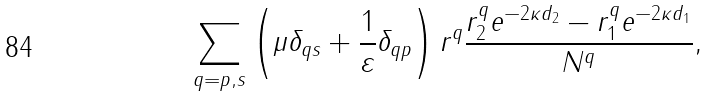<formula> <loc_0><loc_0><loc_500><loc_500>\sum _ { q = p , s } \left ( \mu \delta _ { q s } + \frac { 1 } { \varepsilon } \delta _ { q p } \right ) r ^ { q } \frac { r ^ { q } _ { 2 } e ^ { - 2 \kappa d _ { 2 } } - r ^ { q } _ { 1 } e ^ { - 2 \kappa d _ { 1 } } } { N ^ { q } } ,</formula> 